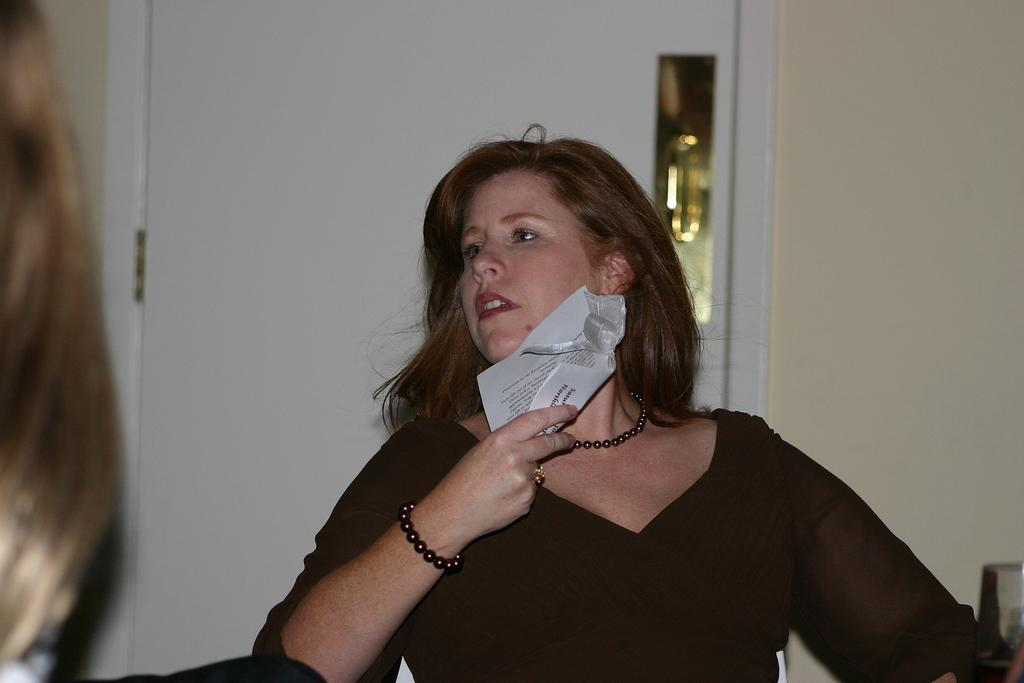Who is present in the image? There is a woman in the image. What is the woman holding in her hand? The woman is holding papers in her hand. What can be seen in the background of the image? There is a door and a wall in the background of the image. What type of note is attached to the cable in the image? There is no note or cable present in the image. 